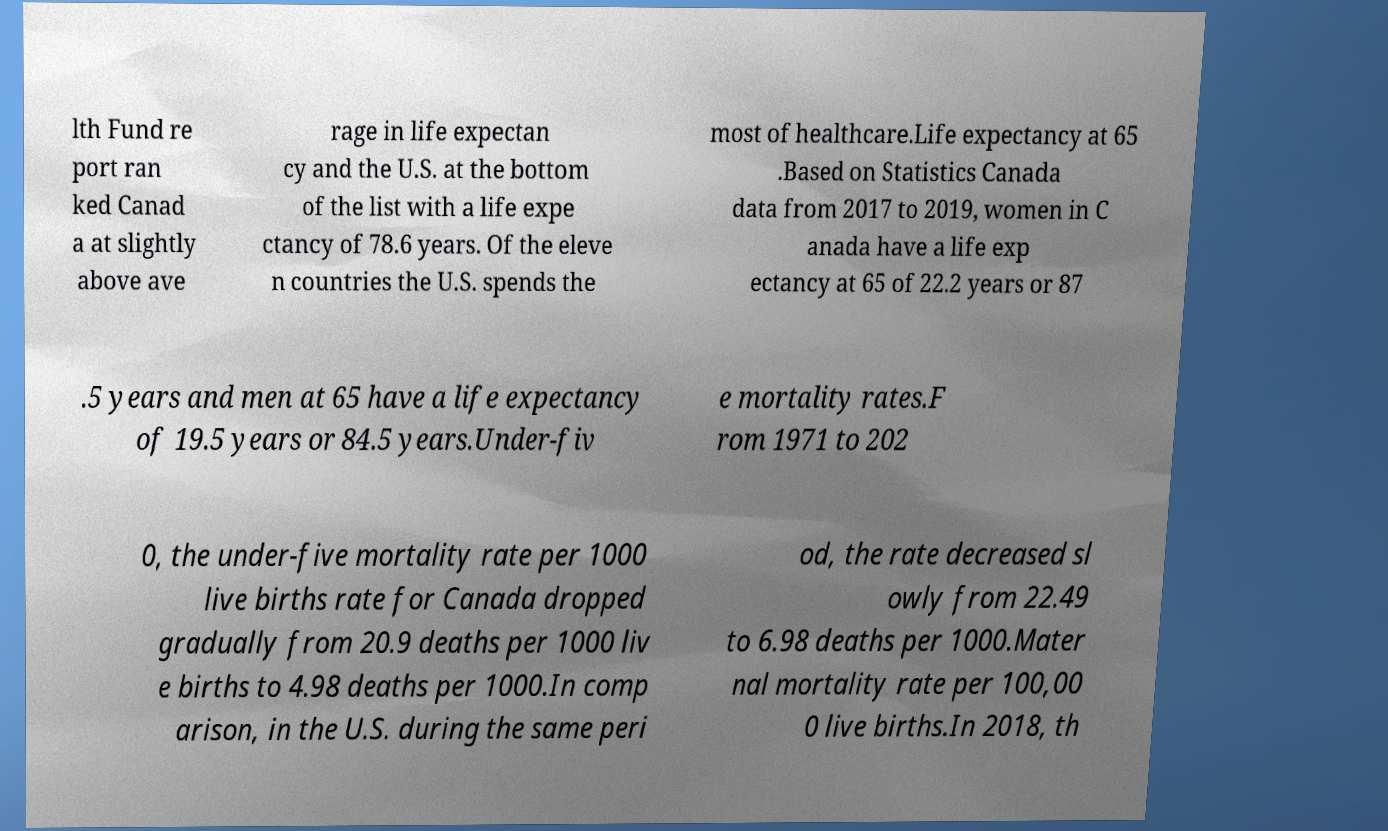Could you assist in decoding the text presented in this image and type it out clearly? lth Fund re port ran ked Canad a at slightly above ave rage in life expectan cy and the U.S. at the bottom of the list with a life expe ctancy of 78.6 years. Of the eleve n countries the U.S. spends the most of healthcare.Life expectancy at 65 .Based on Statistics Canada data from 2017 to 2019, women in C anada have a life exp ectancy at 65 of 22.2 years or 87 .5 years and men at 65 have a life expectancy of 19.5 years or 84.5 years.Under-fiv e mortality rates.F rom 1971 to 202 0, the under-five mortality rate per 1000 live births rate for Canada dropped gradually from 20.9 deaths per 1000 liv e births to 4.98 deaths per 1000.In comp arison, in the U.S. during the same peri od, the rate decreased sl owly from 22.49 to 6.98 deaths per 1000.Mater nal mortality rate per 100,00 0 live births.In 2018, th 